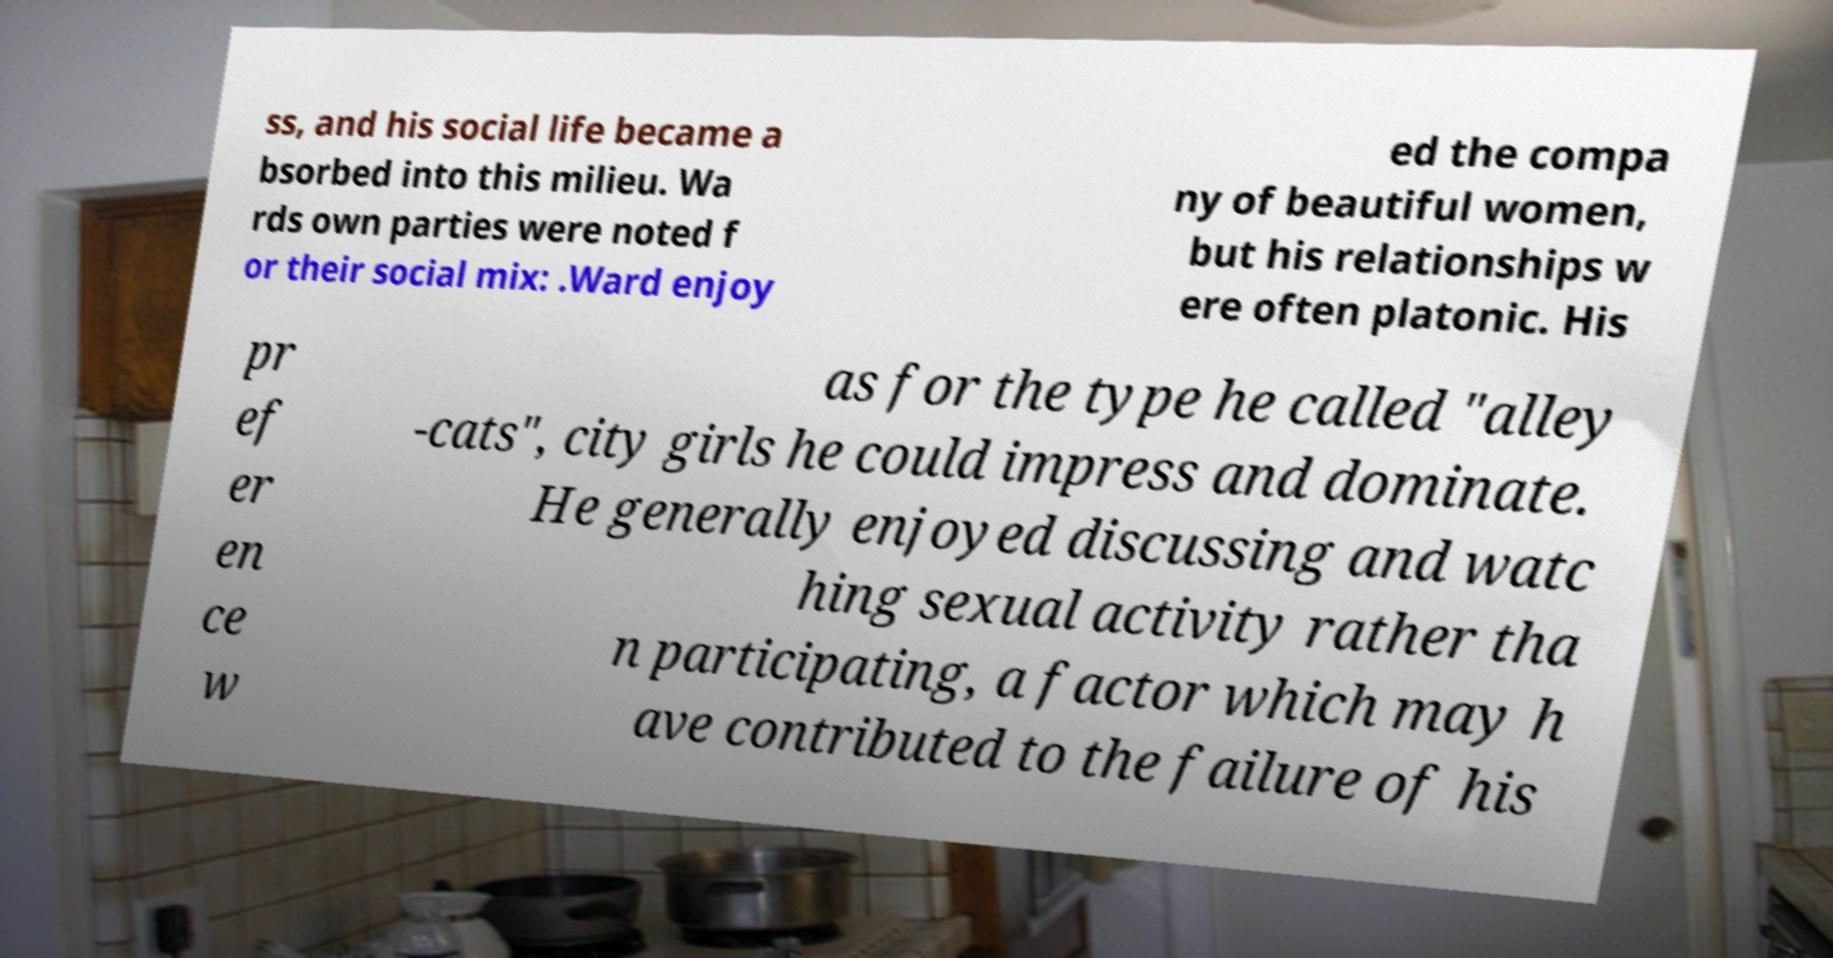Please identify and transcribe the text found in this image. ss, and his social life became a bsorbed into this milieu. Wa rds own parties were noted f or their social mix: .Ward enjoy ed the compa ny of beautiful women, but his relationships w ere often platonic. His pr ef er en ce w as for the type he called "alley -cats", city girls he could impress and dominate. He generally enjoyed discussing and watc hing sexual activity rather tha n participating, a factor which may h ave contributed to the failure of his 